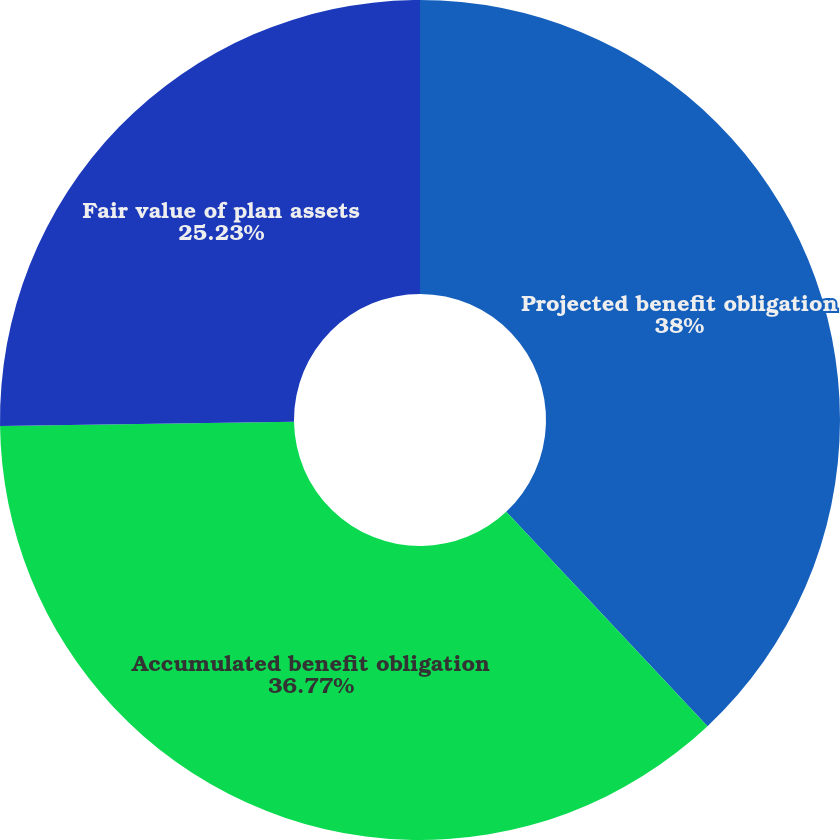Convert chart. <chart><loc_0><loc_0><loc_500><loc_500><pie_chart><fcel>Projected benefit obligation<fcel>Accumulated benefit obligation<fcel>Fair value of plan assets<nl><fcel>38.0%<fcel>36.77%<fcel>25.23%<nl></chart> 